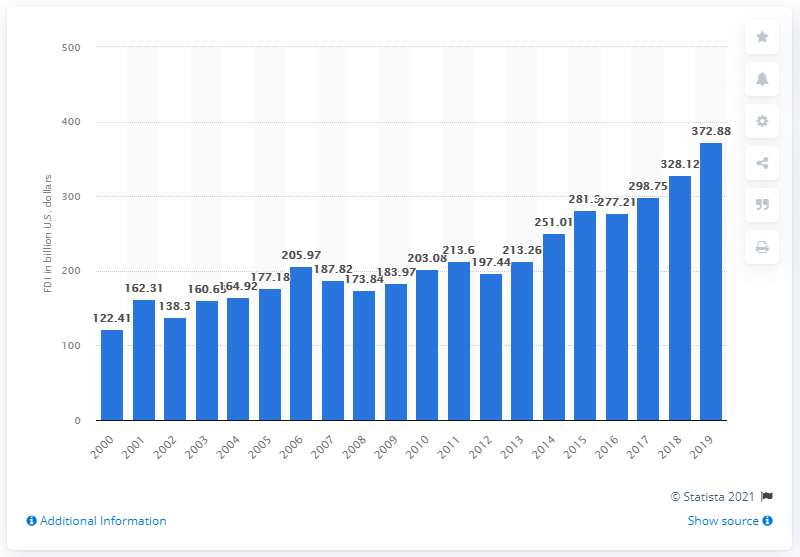Specify some key components in this picture. In 2019, the amount of German foreign direct investments in the U.S. was 372.88. 